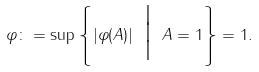<formula> <loc_0><loc_0><loc_500><loc_500>\| \varphi \| \colon = \sup \left \{ | \varphi ( A ) | \ \Big | \ \| A \| = 1 \right \} = 1 .</formula> 